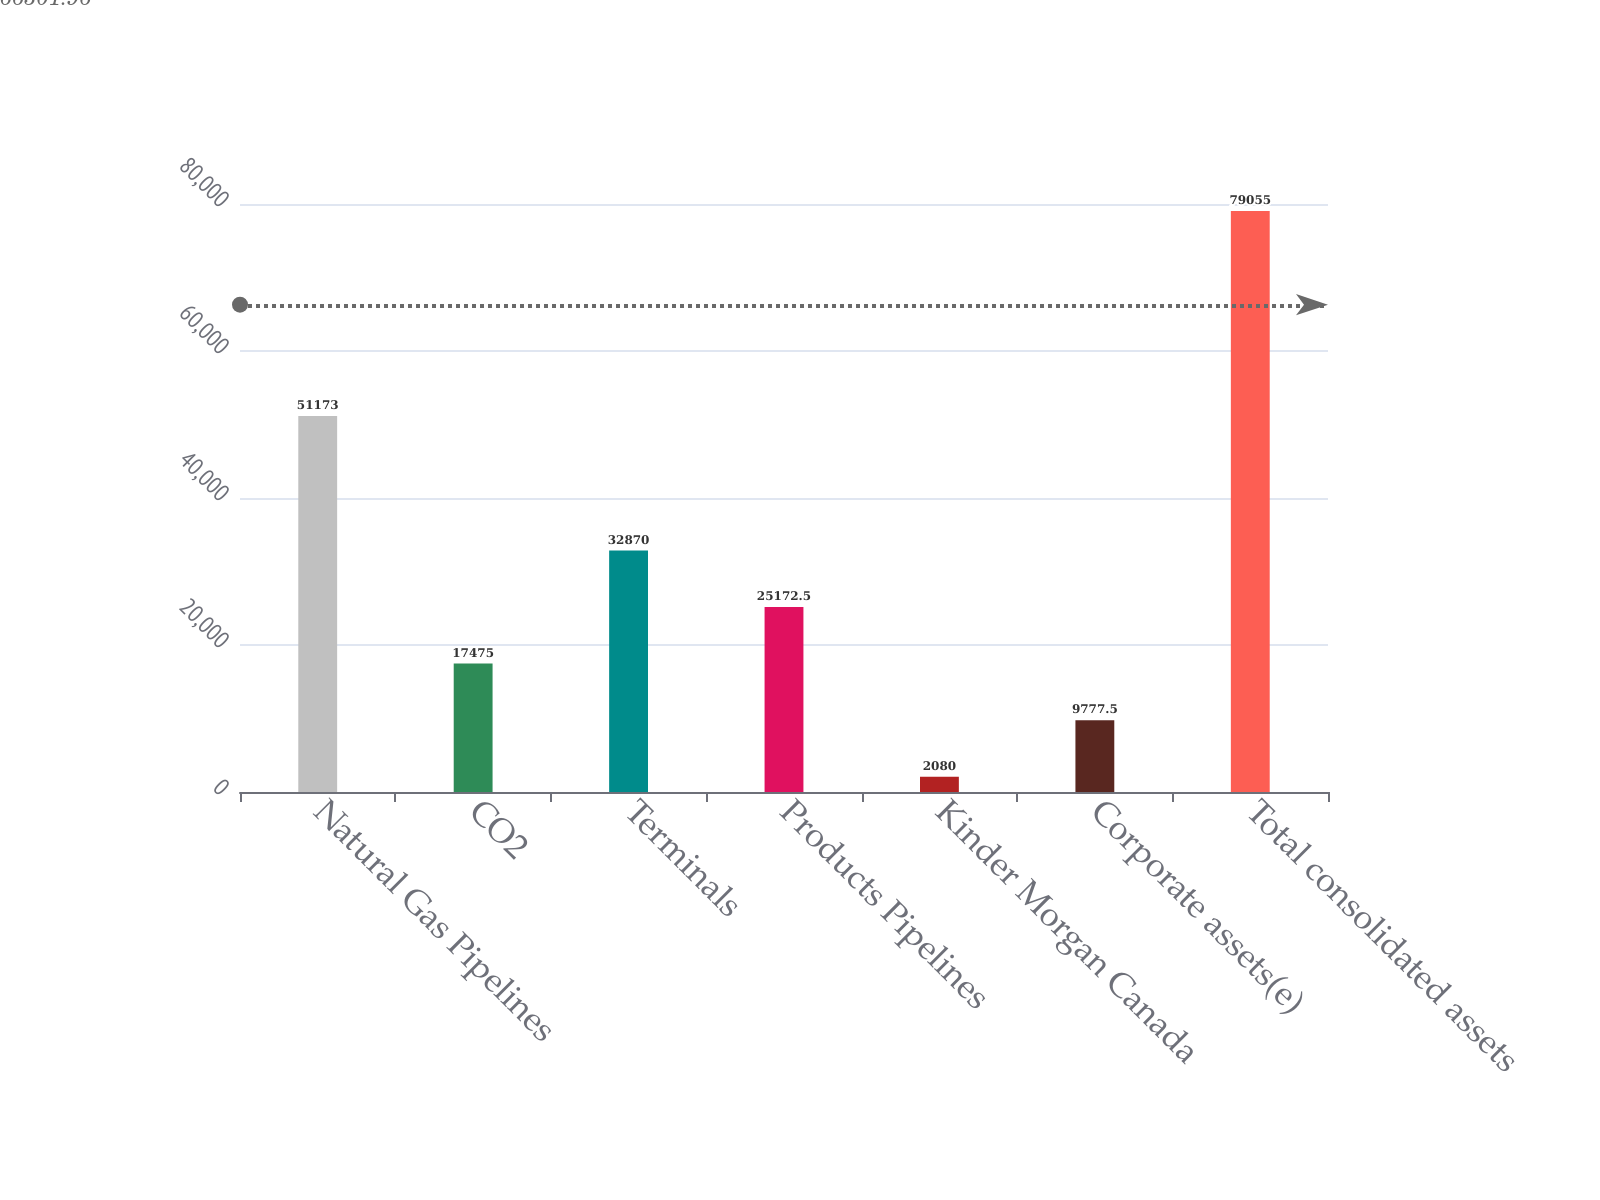Convert chart to OTSL. <chart><loc_0><loc_0><loc_500><loc_500><bar_chart><fcel>Natural Gas Pipelines<fcel>CO2<fcel>Terminals<fcel>Products Pipelines<fcel>Kinder Morgan Canada<fcel>Corporate assets(e)<fcel>Total consolidated assets<nl><fcel>51173<fcel>17475<fcel>32870<fcel>25172.5<fcel>2080<fcel>9777.5<fcel>79055<nl></chart> 